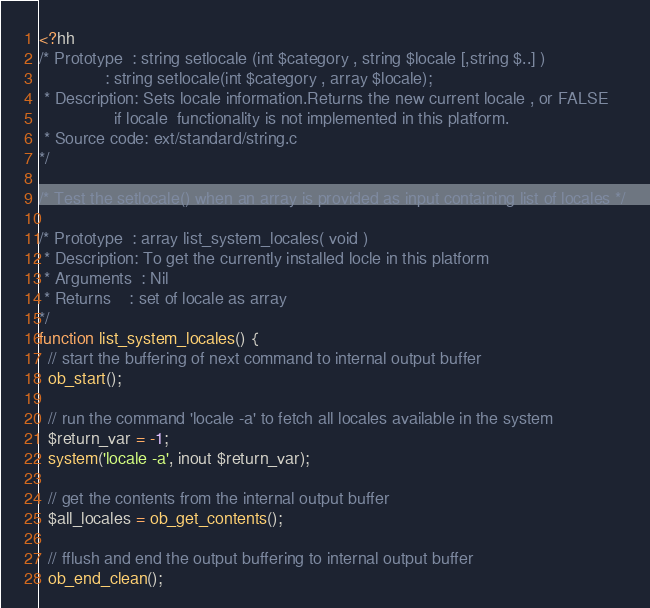Convert code to text. <code><loc_0><loc_0><loc_500><loc_500><_PHP_><?hh
/* Prototype  : string setlocale (int $category , string $locale [,string $..] )
              : string setlocale(int $category , array $locale);
 * Description: Sets locale information.Returns the new current locale , or FALSE
                if locale  functionality is not implemented in this platform.
 * Source code: ext/standard/string.c
*/

/* Test the setlocale() when an array is provided as input containing list of locales */

/* Prototype  : array list_system_locales( void )
 * Description: To get the currently installed locle in this platform
 * Arguments  : Nil
 * Returns    : set of locale as array
*/
function list_system_locales() {
  // start the buffering of next command to internal output buffer
  ob_start();

  // run the command 'locale -a' to fetch all locales available in the system
  $return_var = -1;
  system('locale -a', inout $return_var);

  // get the contents from the internal output buffer
  $all_locales = ob_get_contents();

  // fflush and end the output buffering to internal output buffer
  ob_end_clean();
</code> 